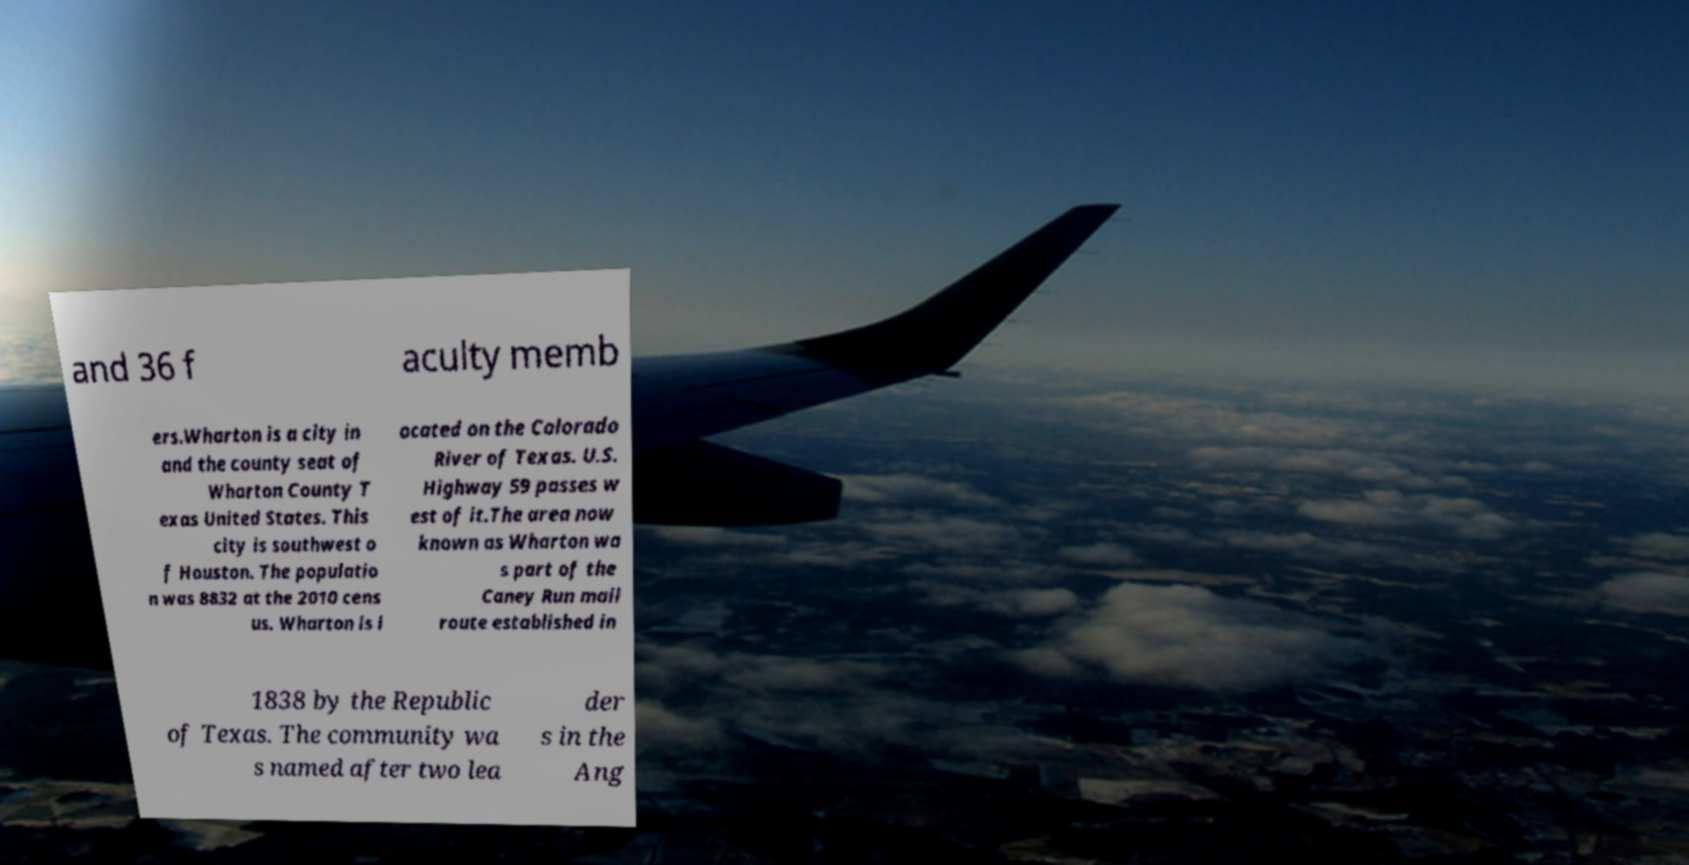Please read and relay the text visible in this image. What does it say? and 36 f aculty memb ers.Wharton is a city in and the county seat of Wharton County T exas United States. This city is southwest o f Houston. The populatio n was 8832 at the 2010 cens us. Wharton is l ocated on the Colorado River of Texas. U.S. Highway 59 passes w est of it.The area now known as Wharton wa s part of the Caney Run mail route established in 1838 by the Republic of Texas. The community wa s named after two lea der s in the Ang 